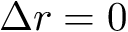Convert formula to latex. <formula><loc_0><loc_0><loc_500><loc_500>\Delta r = 0</formula> 